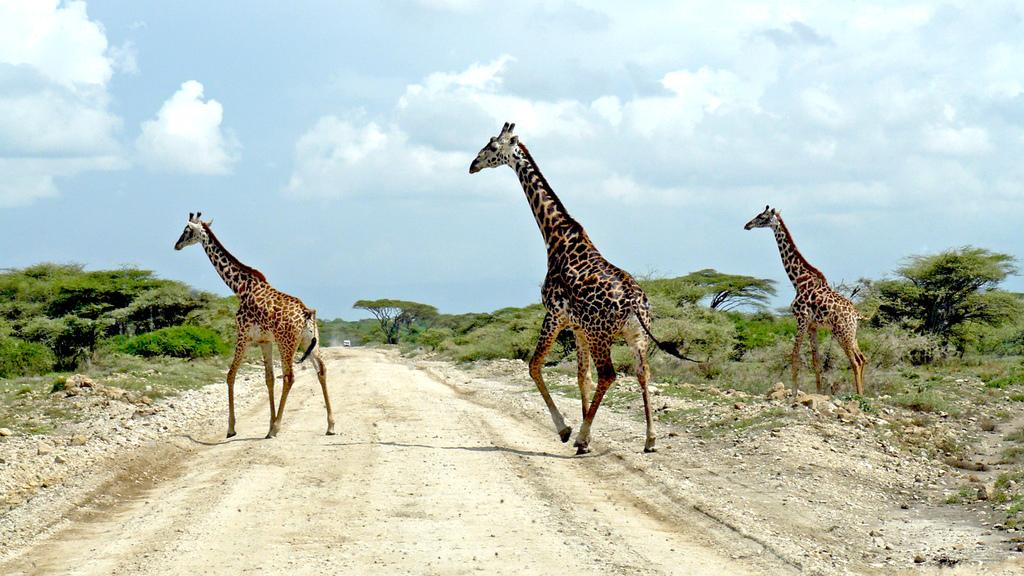How many giraffes are in the image? There are three giraffes in the image. What are the giraffes doing in the image? The giraffes are walking on the road. Can you describe the road in the image? The road contains sand and stones. What can be seen in the background of the image? There are trees in the background of the image. What is visible at the top of the image? The sky is visible at the top of the image. What time of day is it in the image, based on the presence of a donkey? There is no donkey present in the image, so we cannot determine the time of day based on that. 